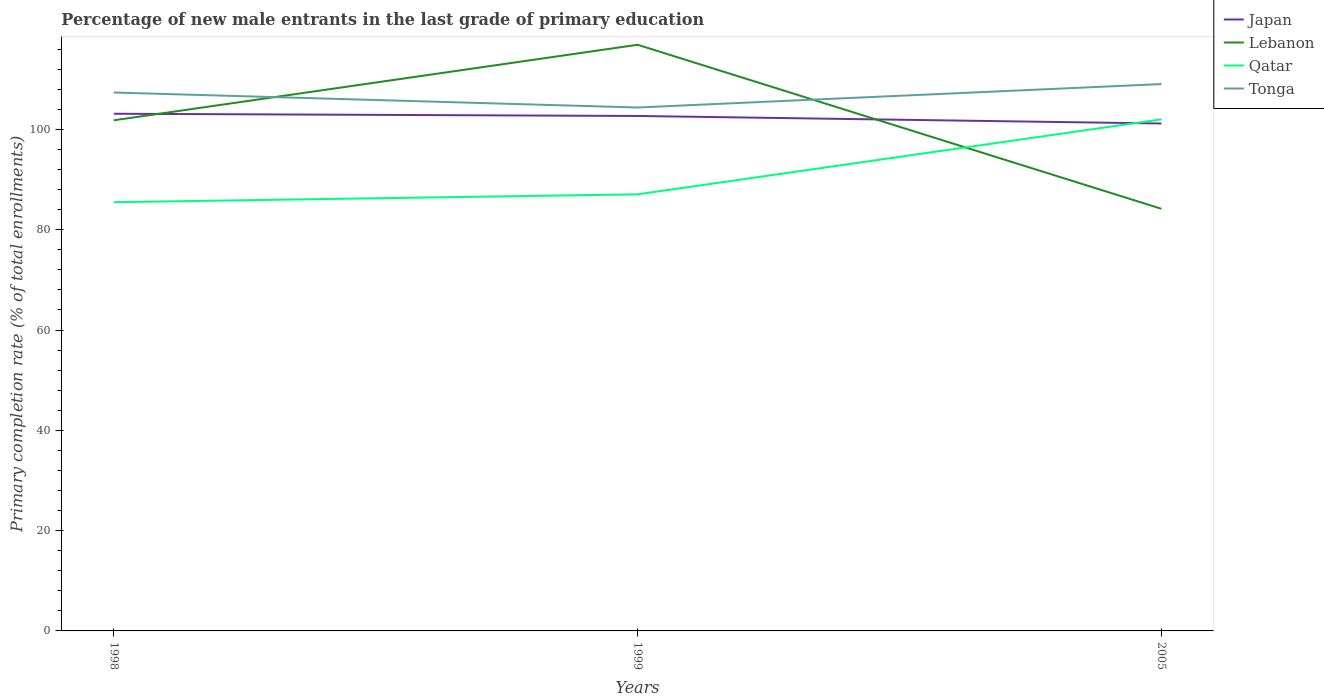Is the number of lines equal to the number of legend labels?
Offer a terse response. Yes. Across all years, what is the maximum percentage of new male entrants in Japan?
Make the answer very short. 101.18. What is the total percentage of new male entrants in Japan in the graph?
Offer a terse response. 0.44. What is the difference between the highest and the second highest percentage of new male entrants in Qatar?
Offer a very short reply. 16.52. What is the difference between the highest and the lowest percentage of new male entrants in Qatar?
Ensure brevity in your answer.  1. Is the percentage of new male entrants in Qatar strictly greater than the percentage of new male entrants in Lebanon over the years?
Keep it short and to the point. No. What is the difference between two consecutive major ticks on the Y-axis?
Make the answer very short. 20. Are the values on the major ticks of Y-axis written in scientific E-notation?
Provide a succinct answer. No. Where does the legend appear in the graph?
Provide a short and direct response. Top right. How are the legend labels stacked?
Keep it short and to the point. Vertical. What is the title of the graph?
Your response must be concise. Percentage of new male entrants in the last grade of primary education. Does "Italy" appear as one of the legend labels in the graph?
Provide a succinct answer. No. What is the label or title of the X-axis?
Your response must be concise. Years. What is the label or title of the Y-axis?
Provide a short and direct response. Primary completion rate (% of total enrollments). What is the Primary completion rate (% of total enrollments) of Japan in 1998?
Provide a short and direct response. 103.12. What is the Primary completion rate (% of total enrollments) in Lebanon in 1998?
Provide a succinct answer. 101.82. What is the Primary completion rate (% of total enrollments) in Qatar in 1998?
Your answer should be very brief. 85.49. What is the Primary completion rate (% of total enrollments) in Tonga in 1998?
Ensure brevity in your answer.  107.36. What is the Primary completion rate (% of total enrollments) in Japan in 1999?
Ensure brevity in your answer.  102.68. What is the Primary completion rate (% of total enrollments) in Lebanon in 1999?
Offer a very short reply. 116.88. What is the Primary completion rate (% of total enrollments) in Qatar in 1999?
Your response must be concise. 87.06. What is the Primary completion rate (% of total enrollments) of Tonga in 1999?
Provide a short and direct response. 104.37. What is the Primary completion rate (% of total enrollments) in Japan in 2005?
Ensure brevity in your answer.  101.18. What is the Primary completion rate (% of total enrollments) in Lebanon in 2005?
Keep it short and to the point. 84.17. What is the Primary completion rate (% of total enrollments) of Qatar in 2005?
Make the answer very short. 102.01. What is the Primary completion rate (% of total enrollments) of Tonga in 2005?
Offer a terse response. 109.04. Across all years, what is the maximum Primary completion rate (% of total enrollments) of Japan?
Provide a succinct answer. 103.12. Across all years, what is the maximum Primary completion rate (% of total enrollments) of Lebanon?
Give a very brief answer. 116.88. Across all years, what is the maximum Primary completion rate (% of total enrollments) of Qatar?
Your response must be concise. 102.01. Across all years, what is the maximum Primary completion rate (% of total enrollments) in Tonga?
Offer a terse response. 109.04. Across all years, what is the minimum Primary completion rate (% of total enrollments) of Japan?
Provide a succinct answer. 101.18. Across all years, what is the minimum Primary completion rate (% of total enrollments) of Lebanon?
Give a very brief answer. 84.17. Across all years, what is the minimum Primary completion rate (% of total enrollments) of Qatar?
Provide a succinct answer. 85.49. Across all years, what is the minimum Primary completion rate (% of total enrollments) of Tonga?
Make the answer very short. 104.37. What is the total Primary completion rate (% of total enrollments) in Japan in the graph?
Keep it short and to the point. 306.98. What is the total Primary completion rate (% of total enrollments) in Lebanon in the graph?
Make the answer very short. 302.86. What is the total Primary completion rate (% of total enrollments) of Qatar in the graph?
Provide a short and direct response. 274.55. What is the total Primary completion rate (% of total enrollments) of Tonga in the graph?
Provide a short and direct response. 320.77. What is the difference between the Primary completion rate (% of total enrollments) in Japan in 1998 and that in 1999?
Offer a terse response. 0.44. What is the difference between the Primary completion rate (% of total enrollments) in Lebanon in 1998 and that in 1999?
Your answer should be compact. -15.06. What is the difference between the Primary completion rate (% of total enrollments) in Qatar in 1998 and that in 1999?
Give a very brief answer. -1.57. What is the difference between the Primary completion rate (% of total enrollments) in Tonga in 1998 and that in 1999?
Offer a terse response. 2.99. What is the difference between the Primary completion rate (% of total enrollments) of Japan in 1998 and that in 2005?
Offer a very short reply. 1.94. What is the difference between the Primary completion rate (% of total enrollments) in Lebanon in 1998 and that in 2005?
Offer a terse response. 17.64. What is the difference between the Primary completion rate (% of total enrollments) of Qatar in 1998 and that in 2005?
Make the answer very short. -16.52. What is the difference between the Primary completion rate (% of total enrollments) of Tonga in 1998 and that in 2005?
Your response must be concise. -1.69. What is the difference between the Primary completion rate (% of total enrollments) in Japan in 1999 and that in 2005?
Provide a succinct answer. 1.5. What is the difference between the Primary completion rate (% of total enrollments) in Lebanon in 1999 and that in 2005?
Your answer should be compact. 32.7. What is the difference between the Primary completion rate (% of total enrollments) in Qatar in 1999 and that in 2005?
Keep it short and to the point. -14.95. What is the difference between the Primary completion rate (% of total enrollments) in Tonga in 1999 and that in 2005?
Your response must be concise. -4.67. What is the difference between the Primary completion rate (% of total enrollments) of Japan in 1998 and the Primary completion rate (% of total enrollments) of Lebanon in 1999?
Your response must be concise. -13.75. What is the difference between the Primary completion rate (% of total enrollments) of Japan in 1998 and the Primary completion rate (% of total enrollments) of Qatar in 1999?
Your answer should be very brief. 16.07. What is the difference between the Primary completion rate (% of total enrollments) of Japan in 1998 and the Primary completion rate (% of total enrollments) of Tonga in 1999?
Offer a terse response. -1.25. What is the difference between the Primary completion rate (% of total enrollments) of Lebanon in 1998 and the Primary completion rate (% of total enrollments) of Qatar in 1999?
Make the answer very short. 14.76. What is the difference between the Primary completion rate (% of total enrollments) in Lebanon in 1998 and the Primary completion rate (% of total enrollments) in Tonga in 1999?
Ensure brevity in your answer.  -2.55. What is the difference between the Primary completion rate (% of total enrollments) of Qatar in 1998 and the Primary completion rate (% of total enrollments) of Tonga in 1999?
Keep it short and to the point. -18.88. What is the difference between the Primary completion rate (% of total enrollments) of Japan in 1998 and the Primary completion rate (% of total enrollments) of Lebanon in 2005?
Give a very brief answer. 18.95. What is the difference between the Primary completion rate (% of total enrollments) in Japan in 1998 and the Primary completion rate (% of total enrollments) in Qatar in 2005?
Offer a very short reply. 1.12. What is the difference between the Primary completion rate (% of total enrollments) of Japan in 1998 and the Primary completion rate (% of total enrollments) of Tonga in 2005?
Provide a short and direct response. -5.92. What is the difference between the Primary completion rate (% of total enrollments) of Lebanon in 1998 and the Primary completion rate (% of total enrollments) of Qatar in 2005?
Provide a succinct answer. -0.19. What is the difference between the Primary completion rate (% of total enrollments) in Lebanon in 1998 and the Primary completion rate (% of total enrollments) in Tonga in 2005?
Your answer should be compact. -7.22. What is the difference between the Primary completion rate (% of total enrollments) of Qatar in 1998 and the Primary completion rate (% of total enrollments) of Tonga in 2005?
Provide a short and direct response. -23.56. What is the difference between the Primary completion rate (% of total enrollments) of Japan in 1999 and the Primary completion rate (% of total enrollments) of Lebanon in 2005?
Provide a succinct answer. 18.51. What is the difference between the Primary completion rate (% of total enrollments) in Japan in 1999 and the Primary completion rate (% of total enrollments) in Qatar in 2005?
Provide a succinct answer. 0.67. What is the difference between the Primary completion rate (% of total enrollments) of Japan in 1999 and the Primary completion rate (% of total enrollments) of Tonga in 2005?
Keep it short and to the point. -6.36. What is the difference between the Primary completion rate (% of total enrollments) of Lebanon in 1999 and the Primary completion rate (% of total enrollments) of Qatar in 2005?
Make the answer very short. 14.87. What is the difference between the Primary completion rate (% of total enrollments) in Lebanon in 1999 and the Primary completion rate (% of total enrollments) in Tonga in 2005?
Offer a very short reply. 7.83. What is the difference between the Primary completion rate (% of total enrollments) of Qatar in 1999 and the Primary completion rate (% of total enrollments) of Tonga in 2005?
Offer a very short reply. -21.99. What is the average Primary completion rate (% of total enrollments) of Japan per year?
Your response must be concise. 102.33. What is the average Primary completion rate (% of total enrollments) of Lebanon per year?
Make the answer very short. 100.95. What is the average Primary completion rate (% of total enrollments) in Qatar per year?
Provide a succinct answer. 91.52. What is the average Primary completion rate (% of total enrollments) in Tonga per year?
Offer a very short reply. 106.92. In the year 1998, what is the difference between the Primary completion rate (% of total enrollments) of Japan and Primary completion rate (% of total enrollments) of Lebanon?
Give a very brief answer. 1.31. In the year 1998, what is the difference between the Primary completion rate (% of total enrollments) in Japan and Primary completion rate (% of total enrollments) in Qatar?
Provide a short and direct response. 17.64. In the year 1998, what is the difference between the Primary completion rate (% of total enrollments) of Japan and Primary completion rate (% of total enrollments) of Tonga?
Your answer should be compact. -4.23. In the year 1998, what is the difference between the Primary completion rate (% of total enrollments) in Lebanon and Primary completion rate (% of total enrollments) in Qatar?
Provide a short and direct response. 16.33. In the year 1998, what is the difference between the Primary completion rate (% of total enrollments) of Lebanon and Primary completion rate (% of total enrollments) of Tonga?
Offer a very short reply. -5.54. In the year 1998, what is the difference between the Primary completion rate (% of total enrollments) in Qatar and Primary completion rate (% of total enrollments) in Tonga?
Provide a succinct answer. -21.87. In the year 1999, what is the difference between the Primary completion rate (% of total enrollments) in Japan and Primary completion rate (% of total enrollments) in Lebanon?
Provide a short and direct response. -14.2. In the year 1999, what is the difference between the Primary completion rate (% of total enrollments) in Japan and Primary completion rate (% of total enrollments) in Qatar?
Your answer should be compact. 15.62. In the year 1999, what is the difference between the Primary completion rate (% of total enrollments) of Japan and Primary completion rate (% of total enrollments) of Tonga?
Offer a terse response. -1.69. In the year 1999, what is the difference between the Primary completion rate (% of total enrollments) of Lebanon and Primary completion rate (% of total enrollments) of Qatar?
Your answer should be compact. 29.82. In the year 1999, what is the difference between the Primary completion rate (% of total enrollments) of Lebanon and Primary completion rate (% of total enrollments) of Tonga?
Your response must be concise. 12.51. In the year 1999, what is the difference between the Primary completion rate (% of total enrollments) of Qatar and Primary completion rate (% of total enrollments) of Tonga?
Provide a succinct answer. -17.31. In the year 2005, what is the difference between the Primary completion rate (% of total enrollments) in Japan and Primary completion rate (% of total enrollments) in Lebanon?
Your response must be concise. 17.01. In the year 2005, what is the difference between the Primary completion rate (% of total enrollments) of Japan and Primary completion rate (% of total enrollments) of Qatar?
Your response must be concise. -0.83. In the year 2005, what is the difference between the Primary completion rate (% of total enrollments) of Japan and Primary completion rate (% of total enrollments) of Tonga?
Offer a very short reply. -7.86. In the year 2005, what is the difference between the Primary completion rate (% of total enrollments) in Lebanon and Primary completion rate (% of total enrollments) in Qatar?
Your answer should be very brief. -17.83. In the year 2005, what is the difference between the Primary completion rate (% of total enrollments) of Lebanon and Primary completion rate (% of total enrollments) of Tonga?
Offer a very short reply. -24.87. In the year 2005, what is the difference between the Primary completion rate (% of total enrollments) in Qatar and Primary completion rate (% of total enrollments) in Tonga?
Offer a very short reply. -7.04. What is the ratio of the Primary completion rate (% of total enrollments) of Lebanon in 1998 to that in 1999?
Your response must be concise. 0.87. What is the ratio of the Primary completion rate (% of total enrollments) of Qatar in 1998 to that in 1999?
Provide a succinct answer. 0.98. What is the ratio of the Primary completion rate (% of total enrollments) of Tonga in 1998 to that in 1999?
Ensure brevity in your answer.  1.03. What is the ratio of the Primary completion rate (% of total enrollments) of Japan in 1998 to that in 2005?
Provide a short and direct response. 1.02. What is the ratio of the Primary completion rate (% of total enrollments) in Lebanon in 1998 to that in 2005?
Ensure brevity in your answer.  1.21. What is the ratio of the Primary completion rate (% of total enrollments) of Qatar in 1998 to that in 2005?
Offer a terse response. 0.84. What is the ratio of the Primary completion rate (% of total enrollments) of Tonga in 1998 to that in 2005?
Make the answer very short. 0.98. What is the ratio of the Primary completion rate (% of total enrollments) of Japan in 1999 to that in 2005?
Give a very brief answer. 1.01. What is the ratio of the Primary completion rate (% of total enrollments) of Lebanon in 1999 to that in 2005?
Make the answer very short. 1.39. What is the ratio of the Primary completion rate (% of total enrollments) of Qatar in 1999 to that in 2005?
Provide a succinct answer. 0.85. What is the ratio of the Primary completion rate (% of total enrollments) of Tonga in 1999 to that in 2005?
Offer a terse response. 0.96. What is the difference between the highest and the second highest Primary completion rate (% of total enrollments) of Japan?
Provide a short and direct response. 0.44. What is the difference between the highest and the second highest Primary completion rate (% of total enrollments) of Lebanon?
Keep it short and to the point. 15.06. What is the difference between the highest and the second highest Primary completion rate (% of total enrollments) in Qatar?
Keep it short and to the point. 14.95. What is the difference between the highest and the second highest Primary completion rate (% of total enrollments) in Tonga?
Ensure brevity in your answer.  1.69. What is the difference between the highest and the lowest Primary completion rate (% of total enrollments) in Japan?
Offer a very short reply. 1.94. What is the difference between the highest and the lowest Primary completion rate (% of total enrollments) of Lebanon?
Ensure brevity in your answer.  32.7. What is the difference between the highest and the lowest Primary completion rate (% of total enrollments) of Qatar?
Your response must be concise. 16.52. What is the difference between the highest and the lowest Primary completion rate (% of total enrollments) in Tonga?
Your answer should be very brief. 4.67. 